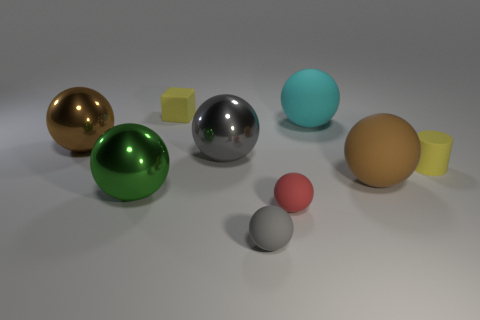Subtract 5 balls. How many balls are left? 2 Subtract all gray spheres. How many spheres are left? 5 Subtract all small gray matte spheres. How many spheres are left? 6 Add 1 big gray shiny balls. How many objects exist? 10 Subtract all purple spheres. Subtract all cyan blocks. How many spheres are left? 7 Subtract all cylinders. How many objects are left? 8 Subtract all tiny red rubber cylinders. Subtract all big cyan rubber objects. How many objects are left? 8 Add 4 tiny yellow matte cubes. How many tiny yellow matte cubes are left? 5 Add 2 small green blocks. How many small green blocks exist? 2 Subtract 0 brown cylinders. How many objects are left? 9 